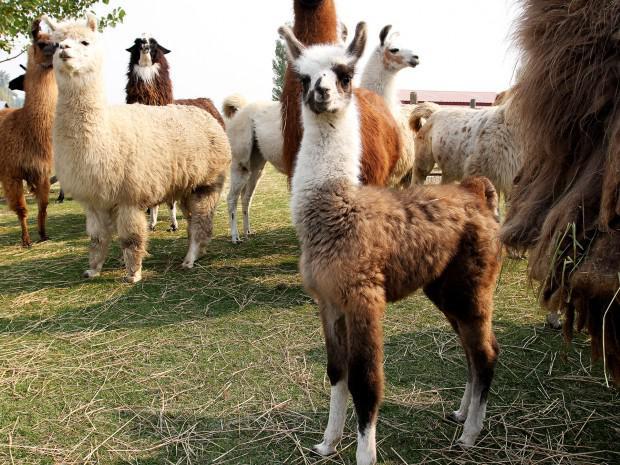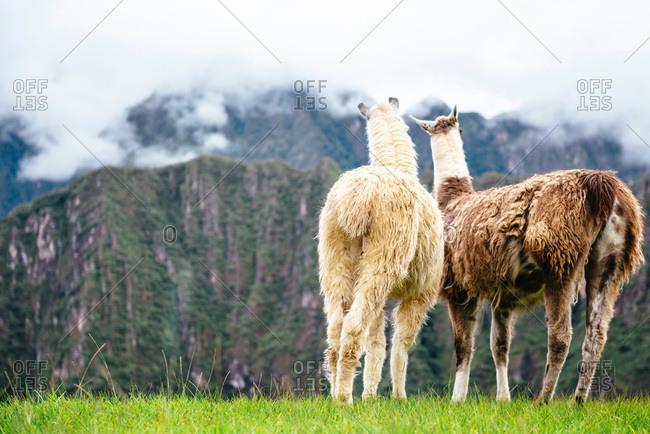The first image is the image on the left, the second image is the image on the right. For the images displayed, is the sentence "The llamas in the image on the right are standing with their sides touching." factually correct? Answer yes or no. Yes. The first image is the image on the left, the second image is the image on the right. Examine the images to the left and right. Is the description "There are llamas next to a wire fence." accurate? Answer yes or no. No. 